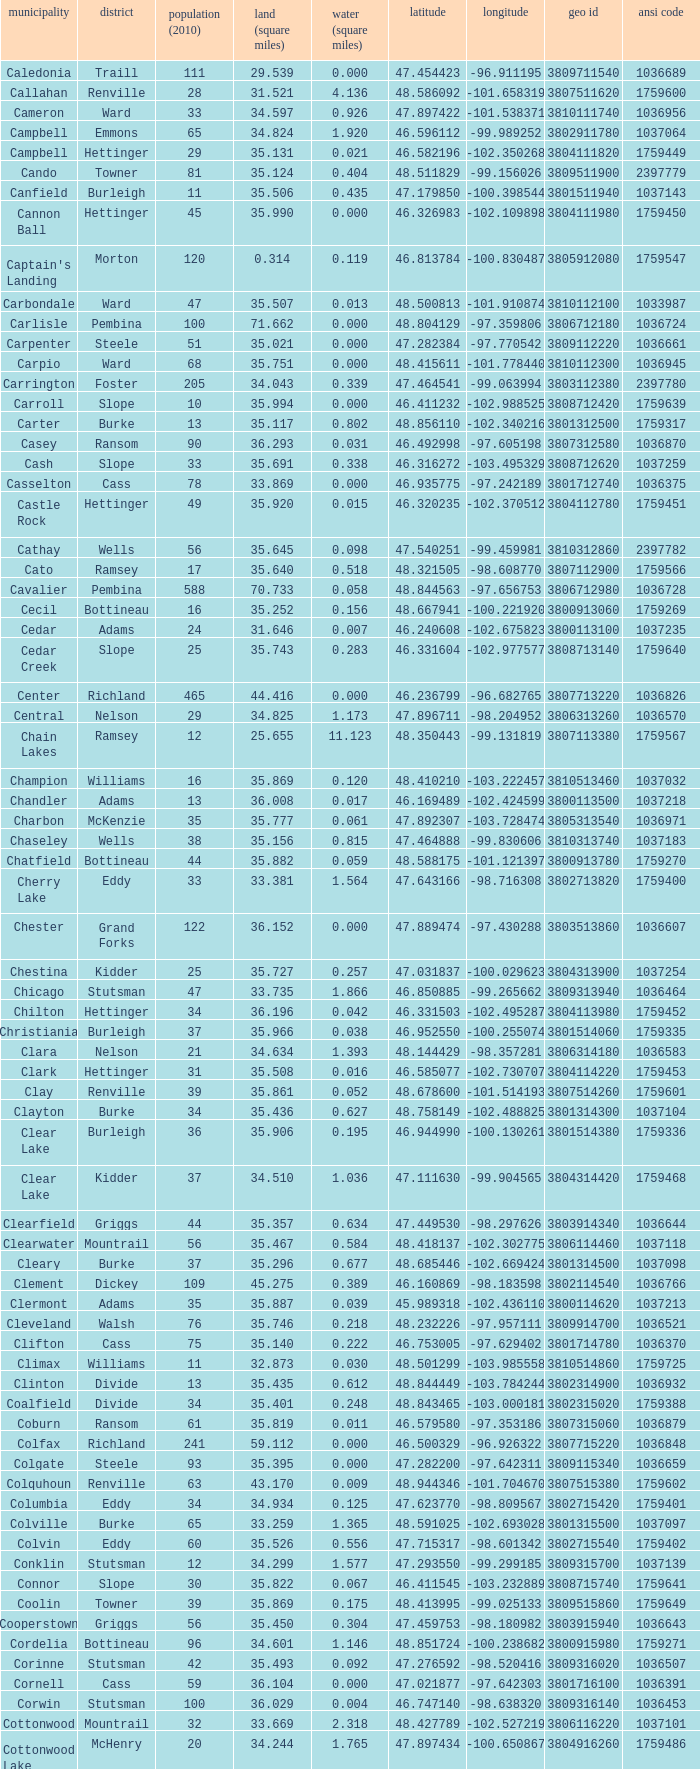Can you parse all the data within this table? {'header': ['municipality', 'district', 'population (2010)', 'land (square miles)', 'water (square miles)', 'latitude', 'longitude', 'geo id', 'ansi code'], 'rows': [['Caledonia', 'Traill', '111', '29.539', '0.000', '47.454423', '-96.911195', '3809711540', '1036689'], ['Callahan', 'Renville', '28', '31.521', '4.136', '48.586092', '-101.658319', '3807511620', '1759600'], ['Cameron', 'Ward', '33', '34.597', '0.926', '47.897422', '-101.538371', '3810111740', '1036956'], ['Campbell', 'Emmons', '65', '34.824', '1.920', '46.596112', '-99.989252', '3802911780', '1037064'], ['Campbell', 'Hettinger', '29', '35.131', '0.021', '46.582196', '-102.350268', '3804111820', '1759449'], ['Cando', 'Towner', '81', '35.124', '0.404', '48.511829', '-99.156026', '3809511900', '2397779'], ['Canfield', 'Burleigh', '11', '35.506', '0.435', '47.179850', '-100.398544', '3801511940', '1037143'], ['Cannon Ball', 'Hettinger', '45', '35.990', '0.000', '46.326983', '-102.109898', '3804111980', '1759450'], ["Captain's Landing", 'Morton', '120', '0.314', '0.119', '46.813784', '-100.830487', '3805912080', '1759547'], ['Carbondale', 'Ward', '47', '35.507', '0.013', '48.500813', '-101.910874', '3810112100', '1033987'], ['Carlisle', 'Pembina', '100', '71.662', '0.000', '48.804129', '-97.359806', '3806712180', '1036724'], ['Carpenter', 'Steele', '51', '35.021', '0.000', '47.282384', '-97.770542', '3809112220', '1036661'], ['Carpio', 'Ward', '68', '35.751', '0.000', '48.415611', '-101.778440', '3810112300', '1036945'], ['Carrington', 'Foster', '205', '34.043', '0.339', '47.464541', '-99.063994', '3803112380', '2397780'], ['Carroll', 'Slope', '10', '35.994', '0.000', '46.411232', '-102.988525', '3808712420', '1759639'], ['Carter', 'Burke', '13', '35.117', '0.802', '48.856110', '-102.340216', '3801312500', '1759317'], ['Casey', 'Ransom', '90', '36.293', '0.031', '46.492998', '-97.605198', '3807312580', '1036870'], ['Cash', 'Slope', '33', '35.691', '0.338', '46.316272', '-103.495329', '3808712620', '1037259'], ['Casselton', 'Cass', '78', '33.869', '0.000', '46.935775', '-97.242189', '3801712740', '1036375'], ['Castle Rock', 'Hettinger', '49', '35.920', '0.015', '46.320235', '-102.370512', '3804112780', '1759451'], ['Cathay', 'Wells', '56', '35.645', '0.098', '47.540251', '-99.459981', '3810312860', '2397782'], ['Cato', 'Ramsey', '17', '35.640', '0.518', '48.321505', '-98.608770', '3807112900', '1759566'], ['Cavalier', 'Pembina', '588', '70.733', '0.058', '48.844563', '-97.656753', '3806712980', '1036728'], ['Cecil', 'Bottineau', '16', '35.252', '0.156', '48.667941', '-100.221920', '3800913060', '1759269'], ['Cedar', 'Adams', '24', '31.646', '0.007', '46.240608', '-102.675823', '3800113100', '1037235'], ['Cedar Creek', 'Slope', '25', '35.743', '0.283', '46.331604', '-102.977577', '3808713140', '1759640'], ['Center', 'Richland', '465', '44.416', '0.000', '46.236799', '-96.682765', '3807713220', '1036826'], ['Central', 'Nelson', '29', '34.825', '1.173', '47.896711', '-98.204952', '3806313260', '1036570'], ['Chain Lakes', 'Ramsey', '12', '25.655', '11.123', '48.350443', '-99.131819', '3807113380', '1759567'], ['Champion', 'Williams', '16', '35.869', '0.120', '48.410210', '-103.222457', '3810513460', '1037032'], ['Chandler', 'Adams', '13', '36.008', '0.017', '46.169489', '-102.424599', '3800113500', '1037218'], ['Charbon', 'McKenzie', '35', '35.777', '0.061', '47.892307', '-103.728474', '3805313540', '1036971'], ['Chaseley', 'Wells', '38', '35.156', '0.815', '47.464888', '-99.830606', '3810313740', '1037183'], ['Chatfield', 'Bottineau', '44', '35.882', '0.059', '48.588175', '-101.121397', '3800913780', '1759270'], ['Cherry Lake', 'Eddy', '33', '33.381', '1.564', '47.643166', '-98.716308', '3802713820', '1759400'], ['Chester', 'Grand Forks', '122', '36.152', '0.000', '47.889474', '-97.430288', '3803513860', '1036607'], ['Chestina', 'Kidder', '25', '35.727', '0.257', '47.031837', '-100.029623', '3804313900', '1037254'], ['Chicago', 'Stutsman', '47', '33.735', '1.866', '46.850885', '-99.265662', '3809313940', '1036464'], ['Chilton', 'Hettinger', '34', '36.196', '0.042', '46.331503', '-102.495287', '3804113980', '1759452'], ['Christiania', 'Burleigh', '37', '35.966', '0.038', '46.952550', '-100.255074', '3801514060', '1759335'], ['Clara', 'Nelson', '21', '34.634', '1.393', '48.144429', '-98.357281', '3806314180', '1036583'], ['Clark', 'Hettinger', '31', '35.508', '0.016', '46.585077', '-102.730707', '3804114220', '1759453'], ['Clay', 'Renville', '39', '35.861', '0.052', '48.678600', '-101.514193', '3807514260', '1759601'], ['Clayton', 'Burke', '34', '35.436', '0.627', '48.758149', '-102.488825', '3801314300', '1037104'], ['Clear Lake', 'Burleigh', '36', '35.906', '0.195', '46.944990', '-100.130261', '3801514380', '1759336'], ['Clear Lake', 'Kidder', '37', '34.510', '1.036', '47.111630', '-99.904565', '3804314420', '1759468'], ['Clearfield', 'Griggs', '44', '35.357', '0.634', '47.449530', '-98.297626', '3803914340', '1036644'], ['Clearwater', 'Mountrail', '56', '35.467', '0.584', '48.418137', '-102.302775', '3806114460', '1037118'], ['Cleary', 'Burke', '37', '35.296', '0.677', '48.685446', '-102.669424', '3801314500', '1037098'], ['Clement', 'Dickey', '109', '45.275', '0.389', '46.160869', '-98.183598', '3802114540', '1036766'], ['Clermont', 'Adams', '35', '35.887', '0.039', '45.989318', '-102.436110', '3800114620', '1037213'], ['Cleveland', 'Walsh', '76', '35.746', '0.218', '48.232226', '-97.957111', '3809914700', '1036521'], ['Clifton', 'Cass', '75', '35.140', '0.222', '46.753005', '-97.629402', '3801714780', '1036370'], ['Climax', 'Williams', '11', '32.873', '0.030', '48.501299', '-103.985558', '3810514860', '1759725'], ['Clinton', 'Divide', '13', '35.435', '0.612', '48.844449', '-103.784244', '3802314900', '1036932'], ['Coalfield', 'Divide', '34', '35.401', '0.248', '48.843465', '-103.000181', '3802315020', '1759388'], ['Coburn', 'Ransom', '61', '35.819', '0.011', '46.579580', '-97.353186', '3807315060', '1036879'], ['Colfax', 'Richland', '241', '59.112', '0.000', '46.500329', '-96.926322', '3807715220', '1036848'], ['Colgate', 'Steele', '93', '35.395', '0.000', '47.282200', '-97.642311', '3809115340', '1036659'], ['Colquhoun', 'Renville', '63', '43.170', '0.009', '48.944346', '-101.704670', '3807515380', '1759602'], ['Columbia', 'Eddy', '34', '34.934', '0.125', '47.623770', '-98.809567', '3802715420', '1759401'], ['Colville', 'Burke', '65', '33.259', '1.365', '48.591025', '-102.693028', '3801315500', '1037097'], ['Colvin', 'Eddy', '60', '35.526', '0.556', '47.715317', '-98.601342', '3802715540', '1759402'], ['Conklin', 'Stutsman', '12', '34.299', '1.577', '47.293550', '-99.299185', '3809315700', '1037139'], ['Connor', 'Slope', '30', '35.822', '0.067', '46.411545', '-103.232889', '3808715740', '1759641'], ['Coolin', 'Towner', '39', '35.869', '0.175', '48.413995', '-99.025133', '3809515860', '1759649'], ['Cooperstown', 'Griggs', '56', '35.450', '0.304', '47.459753', '-98.180982', '3803915940', '1036643'], ['Cordelia', 'Bottineau', '96', '34.601', '1.146', '48.851724', '-100.238682', '3800915980', '1759271'], ['Corinne', 'Stutsman', '42', '35.493', '0.092', '47.276592', '-98.520416', '3809316020', '1036507'], ['Cornell', 'Cass', '59', '36.104', '0.000', '47.021877', '-97.642303', '3801716100', '1036391'], ['Corwin', 'Stutsman', '100', '36.029', '0.004', '46.747140', '-98.638320', '3809316140', '1036453'], ['Cottonwood', 'Mountrail', '32', '33.669', '2.318', '48.427789', '-102.527219', '3806116220', '1037101'], ['Cottonwood Lake', 'McHenry', '20', '34.244', '1.765', '47.897434', '-100.650867', '3804916260', '1759486'], ['Coulee', 'Ramsey', '65', '35.293', '0.216', '48.235617', '-99.126223', '3807116340', '1759568'], ['Courtenay', 'Stutsman', '36', '35.235', '0.257', '47.189672', '-98.530868', '3809316420', '1036497'], ['Crane Creek', 'Mountrail', '84', '35.704', '0.278', '48.074507', '-102.380242', '3806116540', '1037041'], ['Crawford', 'Slope', '31', '35.892', '0.051', '46.320329', '-103.729934', '3808716620', '1037166'], ['Creel', 'Ramsey', '1305', '14.578', '15.621', '48.075823', '-98.857272', '3807116660', '1759569'], ['Cremerville', 'McLean', '27', '35.739', '0.054', '47.811011', '-102.054883', '3805516700', '1759530'], ['Crocus', 'Towner', '44', '35.047', '0.940', '48.667289', '-99.155787', '3809516820', '1759650'], ['Crofte', 'Burleigh', '199', '36.163', '0.000', '47.026425', '-100.685988', '3801516860', '1037131'], ['Cromwell', 'Burleigh', '35', '36.208', '0.000', '47.026008', '-100.558805', '3801516900', '1037133'], ['Crowfoot', 'Mountrail', '18', '34.701', '1.283', '48.495946', '-102.180433', '3806116980', '1037050'], ['Crown Hill', 'Kidder', '7', '30.799', '1.468', '46.770977', '-100.025924', '3804317020', '1759469'], ['Crystal', 'Pembina', '50', '35.499', '0.000', '48.586423', '-97.732145', '3806717100', '1036718'], ['Crystal Lake', 'Wells', '32', '35.522', '0.424', '47.541346', '-99.974737', '3810317140', '1037152'], ['Crystal Springs', 'Kidder', '32', '35.415', '0.636', '46.848792', '-99.529639', '3804317220', '1759470'], ['Cuba', 'Barnes', '76', '35.709', '0.032', '46.851144', '-97.860271', '3800317300', '1036409'], ['Cusator', 'Stutsman', '26', '34.878', '0.693', '46.746853', '-98.997611', '3809317460', '1036459'], ['Cut Bank', 'Bottineau', '37', '35.898', '0.033', '48.763937', '-101.430571', '3800917540', '1759272']]} What was the county with a longitude of -102.302775? Mountrail. 